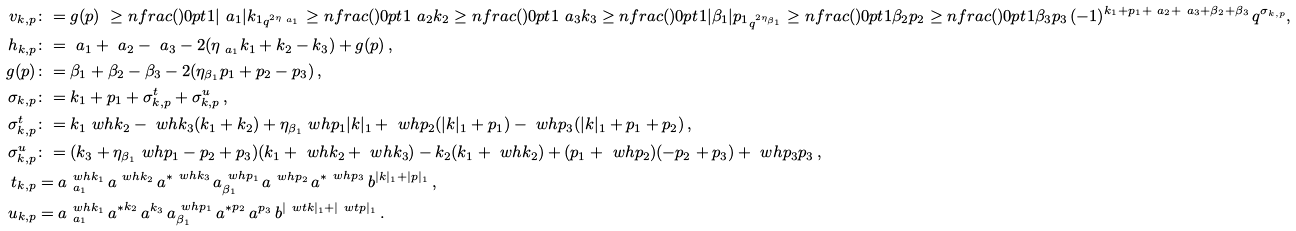<formula> <loc_0><loc_0><loc_500><loc_500>v _ { k , p } & \colon = g ( p ) \ \geq n f r a c ( ) { 0 p t } { 1 } { | { \ a _ { 1 } } | } { k _ { 1 } } _ { q ^ { 2 \eta _ { \ a _ { 1 } } } } \geq n f r a c ( ) { 0 p t } { 1 } { \ a _ { 2 } } { k _ { 2 } } \geq n f r a c ( ) { 0 p t } { 1 } { \ a _ { 3 } } { k _ { 3 } } \geq n f r a c ( ) { 0 p t } { 1 } { | { \beta _ { 1 } } | } { p _ { 1 } } _ { q ^ { 2 \eta _ { \beta _ { 1 } } } } \geq n f r a c ( ) { 0 p t } { 1 } { \beta _ { 2 } } { p _ { 2 } } \geq n f r a c ( ) { 0 p t } { 1 } { \beta _ { 3 } } { p _ { 3 } } \, ( - 1 ) ^ { k _ { 1 } + p _ { 1 } + { \ a _ { 2 } } + { \ a _ { 3 } } + { \beta _ { 2 } } + { \beta _ { 3 } } } \, q ^ { \sigma _ { k , p } } , \\ h _ { k , p } & \colon = { \ a _ { 1 } } + { \ a _ { 2 } } - { \ a _ { 3 } } - 2 ( \eta _ { \ a _ { 1 } } k _ { 1 } + k _ { 2 } - k _ { 3 } ) + g ( p ) \, , \\ g ( p ) & \colon = { \beta _ { 1 } } + { \beta _ { 2 } } - { \beta _ { 3 } } - 2 ( \eta _ { \beta _ { 1 } } p _ { 1 } + p _ { 2 } - p _ { 3 } ) \, , \\ \sigma _ { k , p } & \colon = k _ { 1 } + p _ { 1 } + \sigma ^ { t } _ { k , p } + \sigma ^ { u } _ { k , p } \, , \\ \sigma ^ { t } _ { k , p } & \colon = k _ { 1 } \ w h k _ { 2 } - \ w h k _ { 3 } ( k _ { 1 } + k _ { 2 } ) + \eta _ { \beta _ { 1 } } \ w h p _ { 1 } | k | _ { 1 } + \ w h p _ { 2 } ( | k | _ { 1 } + p _ { 1 } ) - \ w h p _ { 3 } ( | k | _ { 1 } + p _ { 1 } + p _ { 2 } ) \, , \\ \sigma ^ { u } _ { k , p } & \colon = ( k _ { 3 } + \eta _ { \beta _ { 1 } } \ w h p _ { 1 } - p _ { 2 } + p _ { 3 } ) ( k _ { 1 } + \ w h k _ { 2 } + \ w h k _ { 3 } ) - k _ { 2 } ( k _ { 1 } + \ w h k _ { 2 } ) + ( p _ { 1 } + \ w h p _ { 2 } ) ( - p _ { 2 } + p _ { 3 } ) + \ w h p _ { 3 } p _ { 3 } \, , \\ t _ { k , p } & = a _ { \ a _ { 1 } } ^ { \ w h k _ { 1 } } \, a ^ { \ w h k _ { 2 } } \, { a ^ { * } } ^ { \ w h k _ { 3 } } \, a _ { \beta _ { 1 } } ^ { \ w h p _ { 1 } } \, a ^ { \ w h p _ { 2 } } \, { a ^ { * } } ^ { \ w h p _ { 3 } } \, b ^ { | k | _ { 1 } + | p | _ { 1 } } \, , \\ u _ { k , p } & = a _ { \ a _ { 1 } } ^ { \ w h k _ { 1 } } \, { a ^ { * } } ^ { k _ { 2 } } \, a ^ { k _ { 3 } } \, a _ { \beta _ { 1 } } ^ { \ w h p _ { 1 } } \, { a ^ { * } } ^ { p _ { 2 } } \, a ^ { p _ { 3 } } \, b ^ { | \ w t k | _ { 1 } + | \ w t p | _ { 1 } } \, .</formula> 